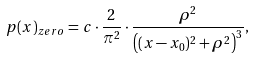Convert formula to latex. <formula><loc_0><loc_0><loc_500><loc_500>p ( x ) _ { z e r o } = c \cdot \frac { 2 } { \pi ^ { 2 } } \cdot \frac { \rho ^ { 2 } } { \left ( ( x - x _ { 0 } ) ^ { 2 } + \rho ^ { 2 } \right ) ^ { 3 } } ,</formula> 